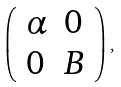Convert formula to latex. <formula><loc_0><loc_0><loc_500><loc_500>\left ( \begin{array} { l l } \alpha & 0 \\ 0 & B \end{array} \right ) ,</formula> 